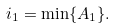Convert formula to latex. <formula><loc_0><loc_0><loc_500><loc_500>i _ { 1 } = \min \{ A _ { 1 } \} .</formula> 